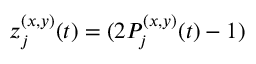Convert formula to latex. <formula><loc_0><loc_0><loc_500><loc_500>z _ { j } ^ { ( x , y ) } ( t ) = ( 2 P _ { j } ^ { ( x , y ) } ( t ) - 1 )</formula> 